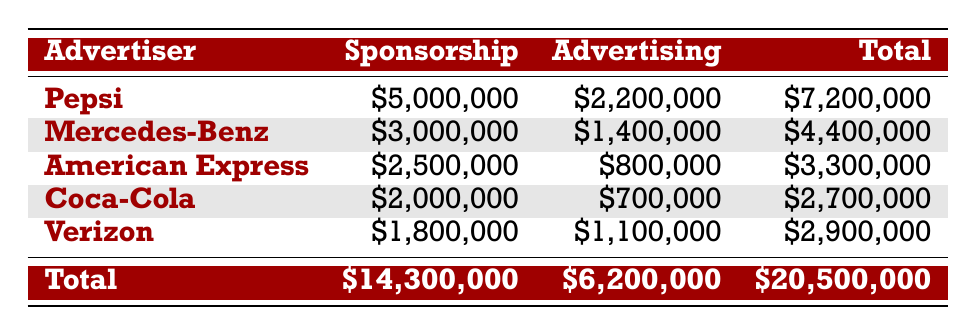What is the total sponsorship amount received from Pepsi? The table lists Pepsi with a sponsorship amount of $5,000,000. This value can be found directly in the sponsorship column next to Pepsi's name.
Answer: 5,000,000 Which advertiser contributed the highest total amount when combining sponsorship and advertising? To find the highest total amount, we look at the Total column. Pepsi has $7,200,000, which is higher than any other advertiser's total. Thus, Pepsi contributed the highest amount.
Answer: Pepsi Is the total advertising amount greater than the total sponsorship amount? The total advertising amount is $6,200,000 and the total sponsorship amount is $14,300,000. Since $6,200,000 is less than $14,300,000, the statement is false.
Answer: No What is the combined sponsorship amount from Coca-Cola and Verizon? Coca-Cola's sponsorship amount is $2,000,000 and Verizon's is $1,800,000. Adding these amounts together gives $2,000,000 + $1,800,000 = $3,800,000.
Answer: 3,800,000 What percentage of the total revenue for the tour does the sponsorship from American Express represent? The total revenue for the tour is $20,500,000. The sponsorship from American Express is $2,500,000. To find the percentage, we calculate (2,500,000 / 20,500,000) * 100, which equals approximately 12.20%.
Answer: 12.20% Which advertiser has the lowest advertising spending and what is the amount? By reviewing the Advertising column, Coca-Cola has the lowest advertising spending of $700,000. This value is found next to Coca-Cola's name in the Advertising column.
Answer: 700,000 How much more did Pepsi spend on advertising campaigns compared to American Express? Pepsi spent $2,200,000 on advertising, while American Express spent $800,000. The difference is calculated as $2,200,000 - $800,000 = $1,400,000.
Answer: 1,400,000 Is it true that Mercedes-Benz's sponsorship amount is higher than the combined advertising amount of Coke and Verizon? Mercedes-Benz has a sponsorship amount of $3,000,000. The combined advertising amount of Coca-Cola ($700,000) and Verizon ($1,100,000) is $1,800,000. Since $3,000,000 is greater than $1,800,000, the statement is true.
Answer: Yes 